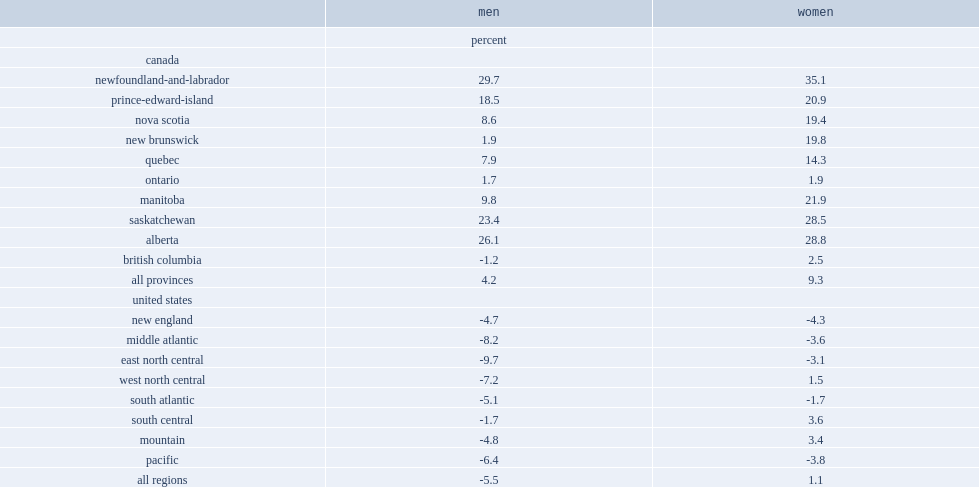Which regions witnessed real median hourly wages of men aged 25 to 54 with no bachelor's degree grew 23% or more from 2000 to 2017? 29.7 23.4 26.1. Which region witnessed real median hourly wages of men aged 25 to 54 with no bachelor's degree increased by only 2% from 2000 to 2017? Ontario. 